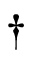<formula> <loc_0><loc_0><loc_500><loc_500>\dag</formula> 